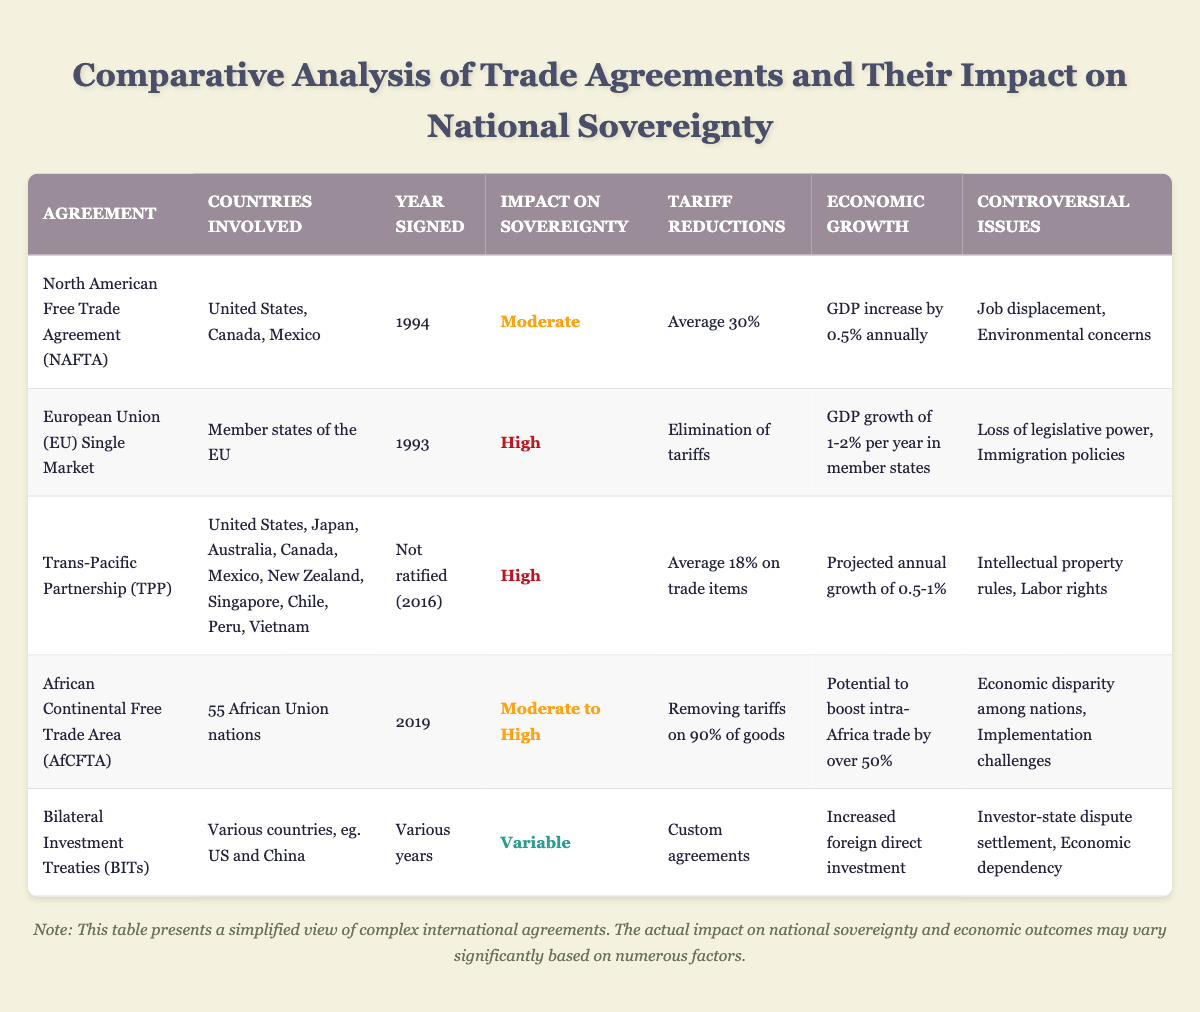What is the impact on sovereignty of the European Union Single Market? According to the table, the European Union Single Market has a "High" impact on sovereignty. This is clearly stated under the "Impact on Sovereignty" column for this agreement.
Answer: High Which trade agreement has the highest average tariff reductions? The agreement mentioned in the table with the highest average tariff reductions is the African Continental Free Trade Area (AfCFTA), which involves removing tariffs on 90% of goods. This is confirmed by comparing the tariff reductions across all agreements listed.
Answer: Removing tariffs on 90% of goods True or False: The TPP was ratified in 2016. In the table, it states that the TPP was "Not ratified (2016)." Therefore, the answer to this question is directly rooted in the information provided.
Answer: False What is the economic growth prediction for the Trans-Pacific Partnership? The table indicates that the economic growth projection for the TPP is an annual growth of 0.5% to 1%. This can be directly referenced from the "Economic Growth" column for that agreement.
Answer: Projected annual growth of 0.5-1% Calculate the average economic growth reported for NAFTA and the EU Single Market. For NAFTA, the economic growth is reported as an increase of 0.5% annually, while for the EU Single Market, the GDP growth is between 1% and 2%, which can be averaged as 1.5%. To calculate the average of these two figures, (0.5 + 1.5) / 2 = 1.0%. Therefore, the average economic growth reported for NAFTA and the EU Single Market is 1%.
Answer: 1% What are the controversial issues related to the African Continental Free Trade Area? The table lists two controversial issues related to the AfCFTA: "Economic disparity among nations" and "Implementation challenges." This information can be found under the "Controversial Issues" column for that agreement.
Answer: Economic disparity among nations, Implementation challenges Is job displacement a controversial issue for the European Union Single Market? Reviewing the "Controversial Issues" column for the EU Single Market, it lists "Loss of legislative power" and "Immigration policies" as the issues, not job displacement. Therefore, the answer is based on the factual presence or absence of the issue in the table.
Answer: No Which trade agreement allows for custom agreements regarding tariff reductions? The Bilateral Investment Treaties (BITs) are noted in the table as having "Custom agreements" regarding tariff reductions. This information is specified under the "Tariff Reductions" column.
Answer: Custom agreements How does the impact on sovereignty vary among the trade agreements listed? The impacts on sovereignty vary as follows: NAFTA has a moderate impact, the EU Single Market and TPP have a high impact, AfCFTA has a moderate to high impact, and BITs have a variable impact. This analysis requires synthesizing information from the "Impact on Sovereignty" column across different agreements.
Answer: Moderate, High, Moderate to High, Variable 